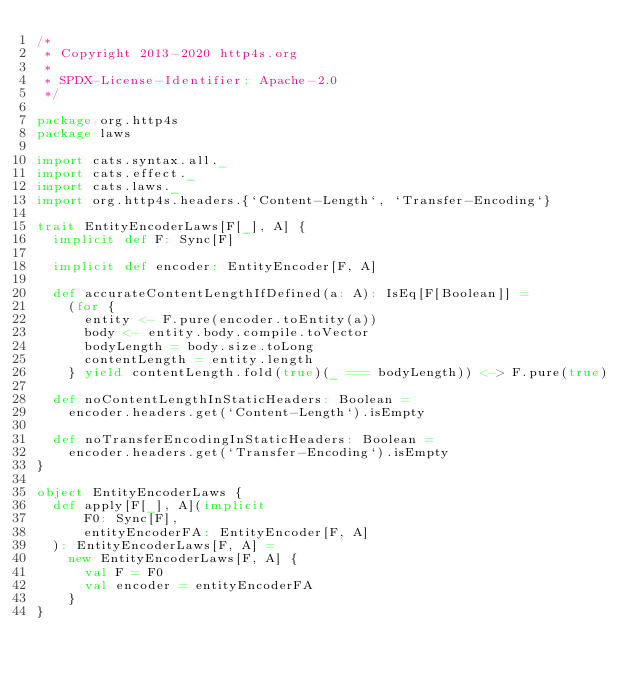<code> <loc_0><loc_0><loc_500><loc_500><_Scala_>/*
 * Copyright 2013-2020 http4s.org
 *
 * SPDX-License-Identifier: Apache-2.0
 */

package org.http4s
package laws

import cats.syntax.all._
import cats.effect._
import cats.laws._
import org.http4s.headers.{`Content-Length`, `Transfer-Encoding`}

trait EntityEncoderLaws[F[_], A] {
  implicit def F: Sync[F]

  implicit def encoder: EntityEncoder[F, A]

  def accurateContentLengthIfDefined(a: A): IsEq[F[Boolean]] =
    (for {
      entity <- F.pure(encoder.toEntity(a))
      body <- entity.body.compile.toVector
      bodyLength = body.size.toLong
      contentLength = entity.length
    } yield contentLength.fold(true)(_ === bodyLength)) <-> F.pure(true)

  def noContentLengthInStaticHeaders: Boolean =
    encoder.headers.get(`Content-Length`).isEmpty

  def noTransferEncodingInStaticHeaders: Boolean =
    encoder.headers.get(`Transfer-Encoding`).isEmpty
}

object EntityEncoderLaws {
  def apply[F[_], A](implicit
      F0: Sync[F],
      entityEncoderFA: EntityEncoder[F, A]
  ): EntityEncoderLaws[F, A] =
    new EntityEncoderLaws[F, A] {
      val F = F0
      val encoder = entityEncoderFA
    }
}
</code> 